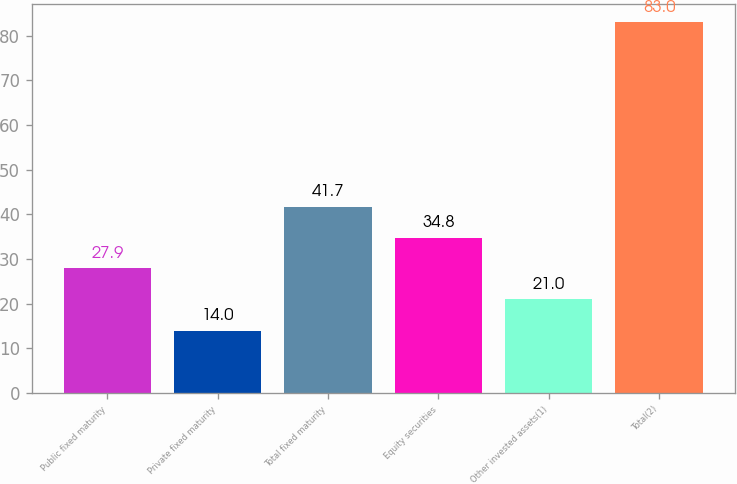Convert chart to OTSL. <chart><loc_0><loc_0><loc_500><loc_500><bar_chart><fcel>Public fixed maturity<fcel>Private fixed maturity<fcel>Total fixed maturity<fcel>Equity securities<fcel>Other invested assets(1)<fcel>Total(2)<nl><fcel>27.9<fcel>14<fcel>41.7<fcel>34.8<fcel>21<fcel>83<nl></chart> 